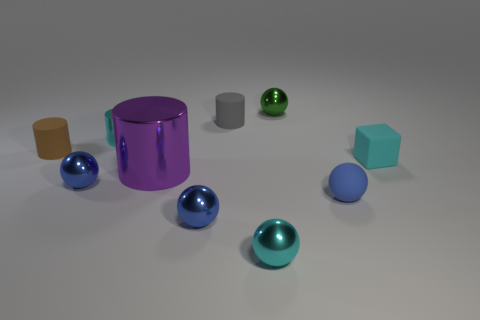Subtract all blue balls. How many were subtracted if there are1blue balls left? 2 Subtract all cyan cubes. How many blue spheres are left? 3 Subtract all cyan balls. How many balls are left? 4 Subtract all tiny rubber balls. How many balls are left? 4 Subtract all purple spheres. Subtract all purple cylinders. How many spheres are left? 5 Subtract all cylinders. How many objects are left? 6 Add 6 rubber cubes. How many rubber cubes are left? 7 Add 7 blue metallic objects. How many blue metallic objects exist? 9 Subtract 0 red cubes. How many objects are left? 10 Subtract all tiny matte objects. Subtract all tiny cyan shiny spheres. How many objects are left? 5 